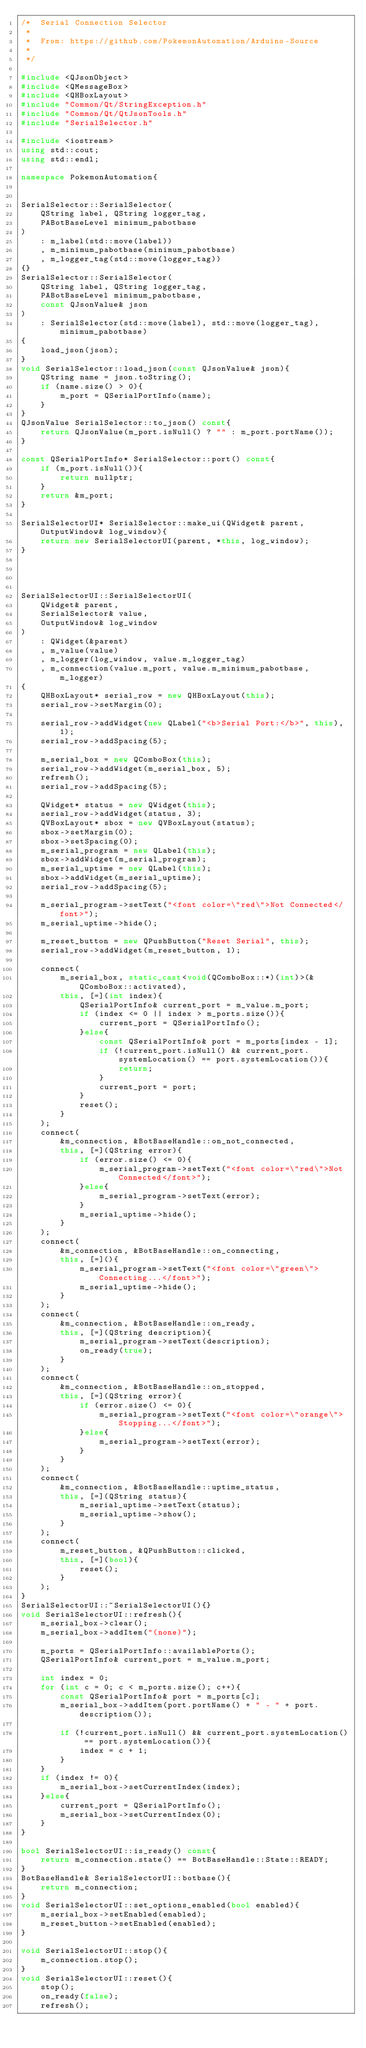<code> <loc_0><loc_0><loc_500><loc_500><_C++_>/*  Serial Connection Selector
 *
 *  From: https://github.com/PokemonAutomation/Arduino-Source
 *
 */

#include <QJsonObject>
#include <QMessageBox>
#include <QHBoxLayout>
#include "Common/Qt/StringException.h"
#include "Common/Qt/QtJsonTools.h"
#include "SerialSelector.h"

#include <iostream>
using std::cout;
using std::endl;

namespace PokemonAutomation{


SerialSelector::SerialSelector(
    QString label, QString logger_tag,
    PABotBaseLevel minimum_pabotbase
)
    : m_label(std::move(label))
    , m_minimum_pabotbase(minimum_pabotbase)
    , m_logger_tag(std::move(logger_tag))
{}
SerialSelector::SerialSelector(
    QString label, QString logger_tag,
    PABotBaseLevel minimum_pabotbase,
    const QJsonValue& json
)
    : SerialSelector(std::move(label), std::move(logger_tag), minimum_pabotbase)
{
    load_json(json);
}
void SerialSelector::load_json(const QJsonValue& json){
    QString name = json.toString();
    if (name.size() > 0){
        m_port = QSerialPortInfo(name);
    }
}
QJsonValue SerialSelector::to_json() const{
    return QJsonValue(m_port.isNull() ? "" : m_port.portName());
}

const QSerialPortInfo* SerialSelector::port() const{
    if (m_port.isNull()){
        return nullptr;
    }
    return &m_port;
}

SerialSelectorUI* SerialSelector::make_ui(QWidget& parent, OutputWindow& log_window){
    return new SerialSelectorUI(parent, *this, log_window);
}




SerialSelectorUI::SerialSelectorUI(
    QWidget& parent,
    SerialSelector& value,
    OutputWindow& log_window
)
    : QWidget(&parent)
    , m_value(value)
    , m_logger(log_window, value.m_logger_tag)
    , m_connection(value.m_port, value.m_minimum_pabotbase, m_logger)
{
    QHBoxLayout* serial_row = new QHBoxLayout(this);
    serial_row->setMargin(0);

    serial_row->addWidget(new QLabel("<b>Serial Port:</b>", this), 1);
    serial_row->addSpacing(5);

    m_serial_box = new QComboBox(this);
    serial_row->addWidget(m_serial_box, 5);
    refresh();
    serial_row->addSpacing(5);

    QWidget* status = new QWidget(this);
    serial_row->addWidget(status, 3);
    QVBoxLayout* sbox = new QVBoxLayout(status);
    sbox->setMargin(0);
    sbox->setSpacing(0);
    m_serial_program = new QLabel(this);
    sbox->addWidget(m_serial_program);
    m_serial_uptime = new QLabel(this);
    sbox->addWidget(m_serial_uptime);
    serial_row->addSpacing(5);

    m_serial_program->setText("<font color=\"red\">Not Connected</font>");
    m_serial_uptime->hide();

    m_reset_button = new QPushButton("Reset Serial", this);
    serial_row->addWidget(m_reset_button, 1);

    connect(
        m_serial_box, static_cast<void(QComboBox::*)(int)>(&QComboBox::activated),
        this, [=](int index){
            QSerialPortInfo& current_port = m_value.m_port;
            if (index <= 0 || index > m_ports.size()){
                current_port = QSerialPortInfo();
            }else{
                const QSerialPortInfo& port = m_ports[index - 1];
                if (!current_port.isNull() && current_port.systemLocation() == port.systemLocation()){
                    return;
                }
                current_port = port;
            }
            reset();
        }
    );
    connect(
        &m_connection, &BotBaseHandle::on_not_connected,
        this, [=](QString error){
            if (error.size() <= 0){
                m_serial_program->setText("<font color=\"red\">Not Connected</font>");
            }else{
                m_serial_program->setText(error);
            }
            m_serial_uptime->hide();
        }
    );
    connect(
        &m_connection, &BotBaseHandle::on_connecting,
        this, [=](){
            m_serial_program->setText("<font color=\"green\">Connecting...</font>");
            m_serial_uptime->hide();
        }
    );
    connect(
        &m_connection, &BotBaseHandle::on_ready,
        this, [=](QString description){
            m_serial_program->setText(description);
            on_ready(true);
        }
    );
    connect(
        &m_connection, &BotBaseHandle::on_stopped,
        this, [=](QString error){
            if (error.size() <= 0){
                m_serial_program->setText("<font color=\"orange\">Stopping...</font>");
            }else{
                m_serial_program->setText(error);
            }
        }
    );
    connect(
        &m_connection, &BotBaseHandle::uptime_status,
        this, [=](QString status){
            m_serial_uptime->setText(status);
            m_serial_uptime->show();
        }
    );
    connect(
        m_reset_button, &QPushButton::clicked,
        this, [=](bool){
            reset();
        }
    );
}
SerialSelectorUI::~SerialSelectorUI(){}
void SerialSelectorUI::refresh(){
    m_serial_box->clear();
    m_serial_box->addItem("(none)");

    m_ports = QSerialPortInfo::availablePorts();
    QSerialPortInfo& current_port = m_value.m_port;

    int index = 0;
    for (int c = 0; c < m_ports.size(); c++){
        const QSerialPortInfo& port = m_ports[c];
        m_serial_box->addItem(port.portName() + " - " + port.description());

        if (!current_port.isNull() && current_port.systemLocation() == port.systemLocation()){
            index = c + 1;
        }
    }
    if (index != 0){
        m_serial_box->setCurrentIndex(index);
    }else{
        current_port = QSerialPortInfo();
        m_serial_box->setCurrentIndex(0);
    }
}

bool SerialSelectorUI::is_ready() const{
    return m_connection.state() == BotBaseHandle::State::READY;
}
BotBaseHandle& SerialSelectorUI::botbase(){
    return m_connection;
}
void SerialSelectorUI::set_options_enabled(bool enabled){
    m_serial_box->setEnabled(enabled);
    m_reset_button->setEnabled(enabled);
}

void SerialSelectorUI::stop(){
    m_connection.stop();
}
void SerialSelectorUI::reset(){
    stop();
    on_ready(false);
    refresh();
</code> 